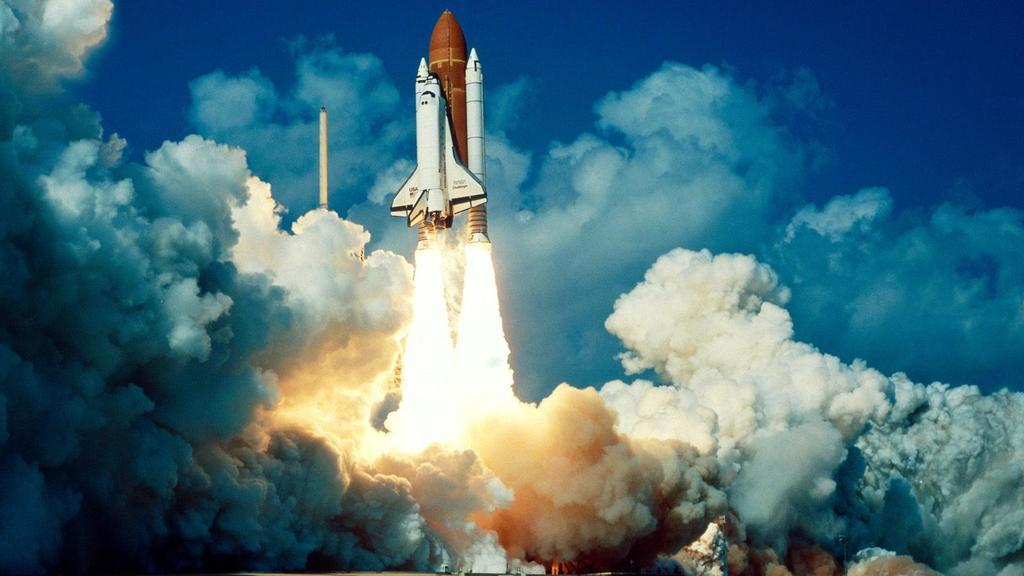What is the main subject of the image? The main subject of the image is a rocket. What is the rocket doing in the image? The rocket is flying in the air. Can you describe any visible effects of the rocket's flight? The rocket is ejecting smoke. What can be seen in the background of the image? There is sky visible in the background of the image. What is the weather like in the image? The presence of clouds in the sky suggests that it is partly cloudy. Where is the crayon located in the image? There is no crayon present in the image. Can you describe the cobweb on the rocket in the image? There is no cobweb on the rocket in the image. 